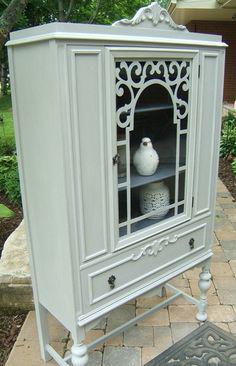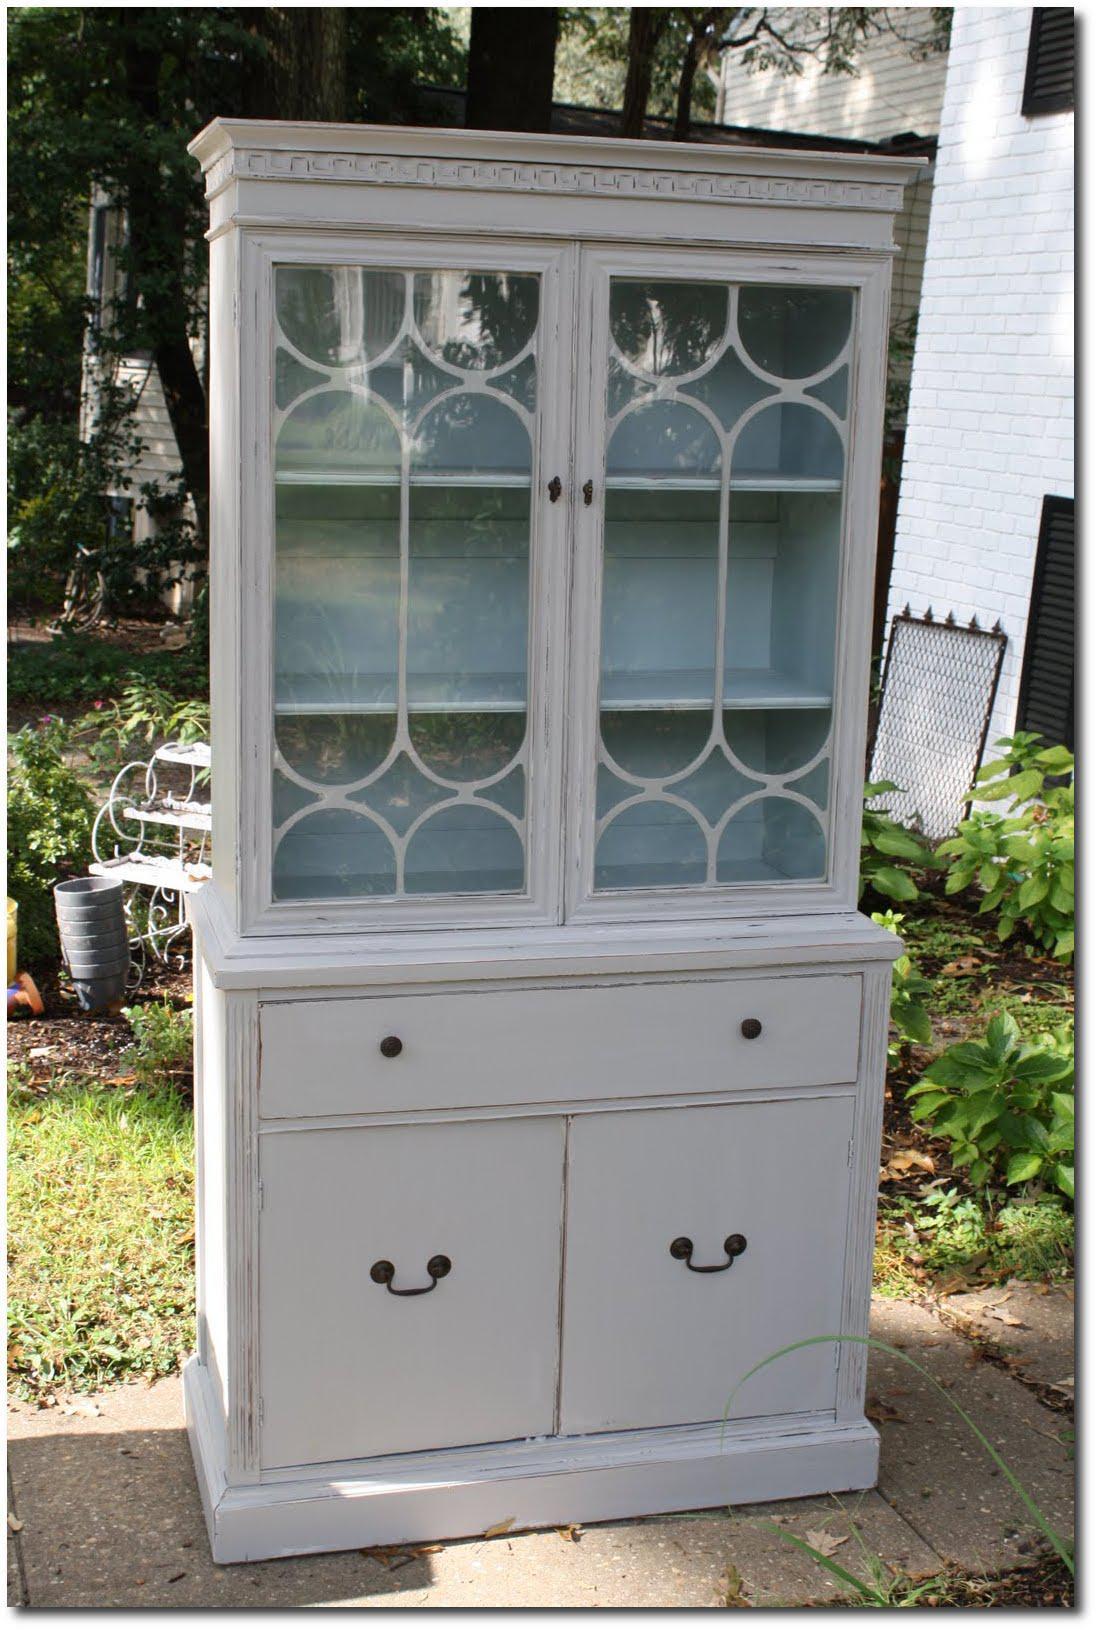The first image is the image on the left, the second image is the image on the right. Assess this claim about the two images: "At least one of the images contains an object inside a hutch.". Correct or not? Answer yes or no. Yes. The first image is the image on the left, the second image is the image on the right. Given the left and right images, does the statement "An image shows a white cabinet with a decorative top element, centered glass panel, and slender legs." hold true? Answer yes or no. Yes. 